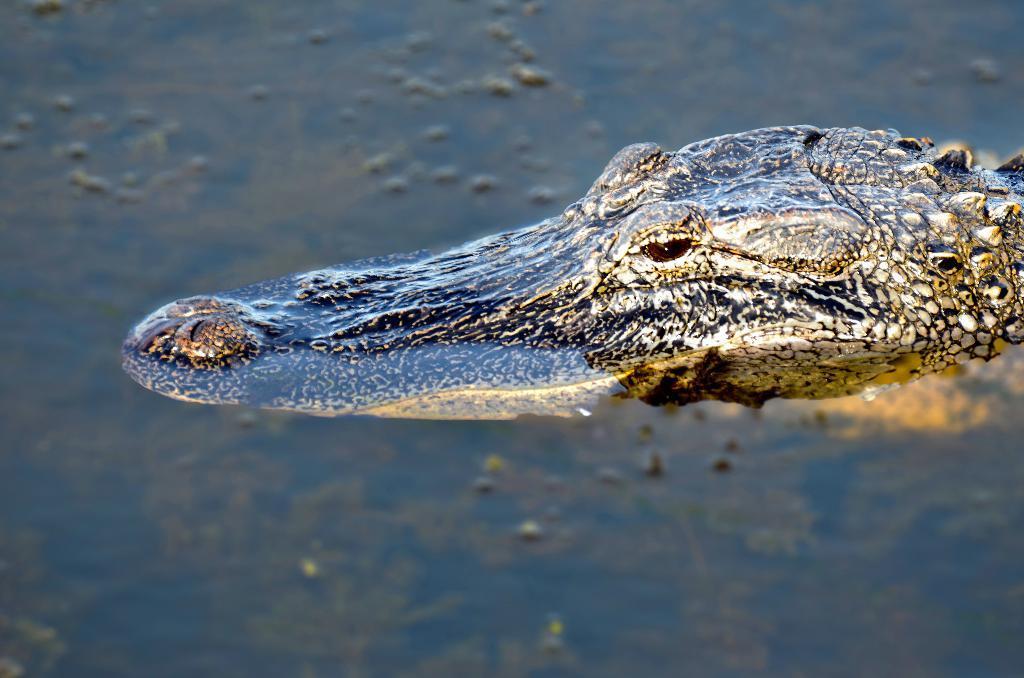Could you give a brief overview of what you see in this image? As we can see in the image there is water and crocodile. 